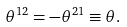<formula> <loc_0><loc_0><loc_500><loc_500>\theta ^ { 1 2 } = - \theta ^ { 2 1 } \equiv \theta .</formula> 